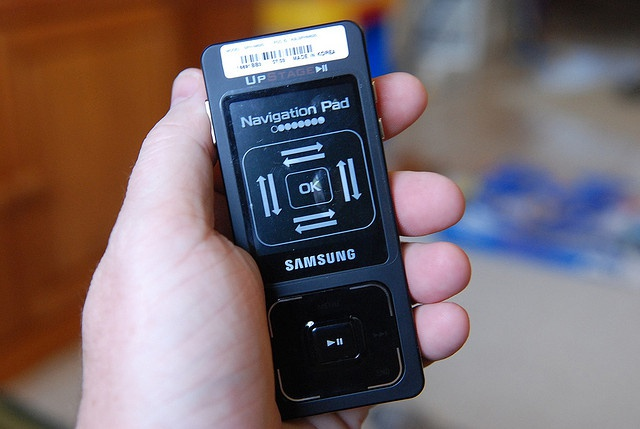Describe the objects in this image and their specific colors. I can see people in maroon, lavender, darkgray, pink, and gray tones and cell phone in maroon, black, navy, blue, and white tones in this image. 